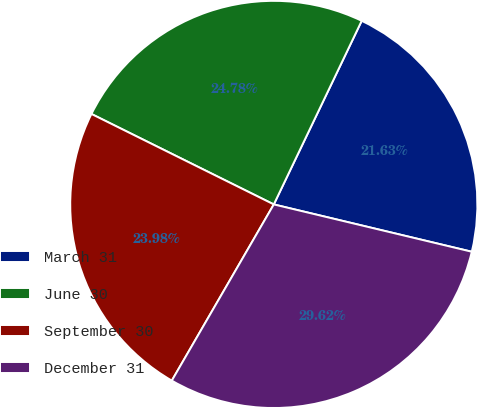Convert chart to OTSL. <chart><loc_0><loc_0><loc_500><loc_500><pie_chart><fcel>March 31<fcel>June 30<fcel>September 30<fcel>December 31<nl><fcel>21.63%<fcel>24.78%<fcel>23.98%<fcel>29.62%<nl></chart> 